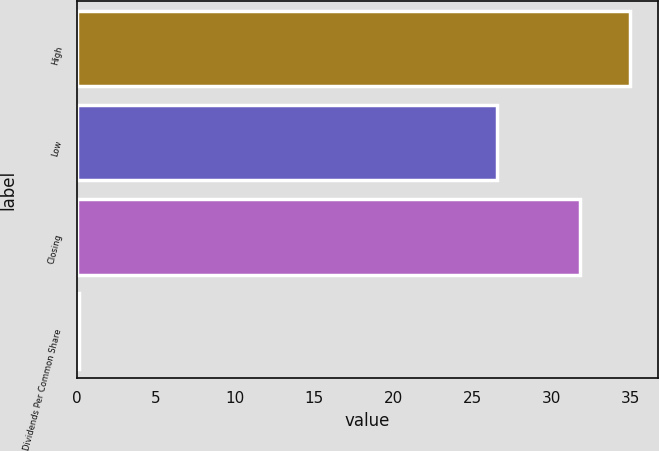<chart> <loc_0><loc_0><loc_500><loc_500><bar_chart><fcel>High<fcel>Low<fcel>Closing<fcel>Dividends Per Common Share<nl><fcel>34.99<fcel>26.57<fcel>31.8<fcel>0.12<nl></chart> 